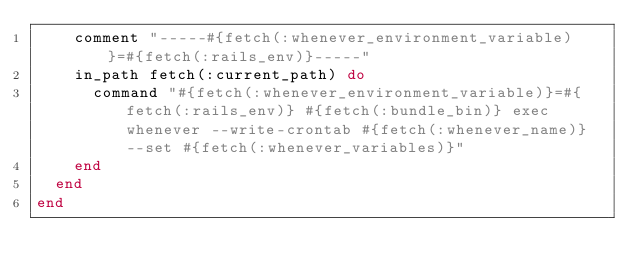Convert code to text. <code><loc_0><loc_0><loc_500><loc_500><_Ruby_>    comment "-----#{fetch(:whenever_environment_variable)}=#{fetch(:rails_env)}-----"
    in_path fetch(:current_path) do
      command "#{fetch(:whenever_environment_variable)}=#{fetch(:rails_env)} #{fetch(:bundle_bin)} exec whenever --write-crontab #{fetch(:whenever_name)} --set #{fetch(:whenever_variables)}"
    end
  end
end
</code> 